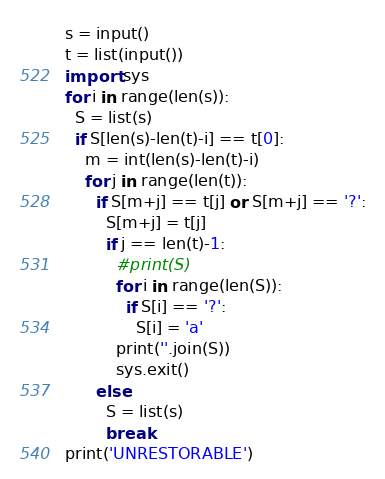<code> <loc_0><loc_0><loc_500><loc_500><_Python_>s = input()
t = list(input())
import sys
for i in range(len(s)):
  S = list(s)
  if S[len(s)-len(t)-i] == t[0]:
    m = int(len(s)-len(t)-i)
    for j in range(len(t)):
      if S[m+j] == t[j] or S[m+j] == '?':
        S[m+j] = t[j]
        if j == len(t)-1:
          #print(S)
          for i in range(len(S)):
            if S[i] == '?':
              S[i] = 'a'
          print(''.join(S))
          sys.exit()
      else:
        S = list(s)
        break
print('UNRESTORABLE')</code> 